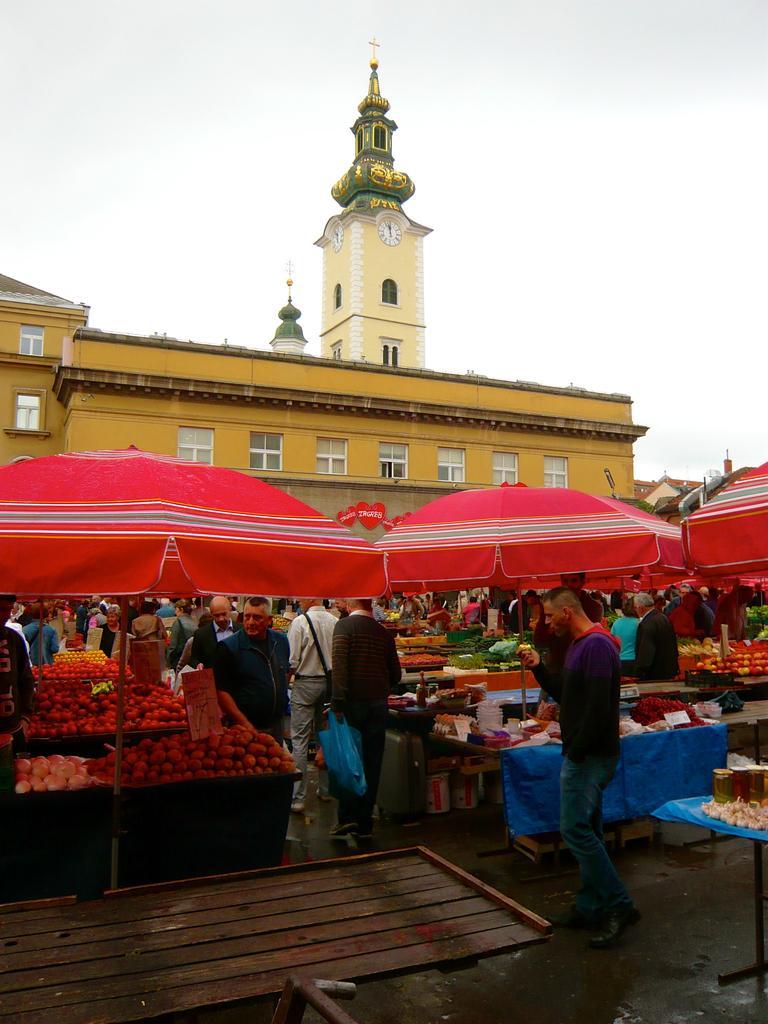Describe this image in one or two sentences. In this image, I can see a building with windows. In front a building, there are umbrellas, fruits and vegetables on the tables and groups of people walking on the road. In the background, there is the sky. 